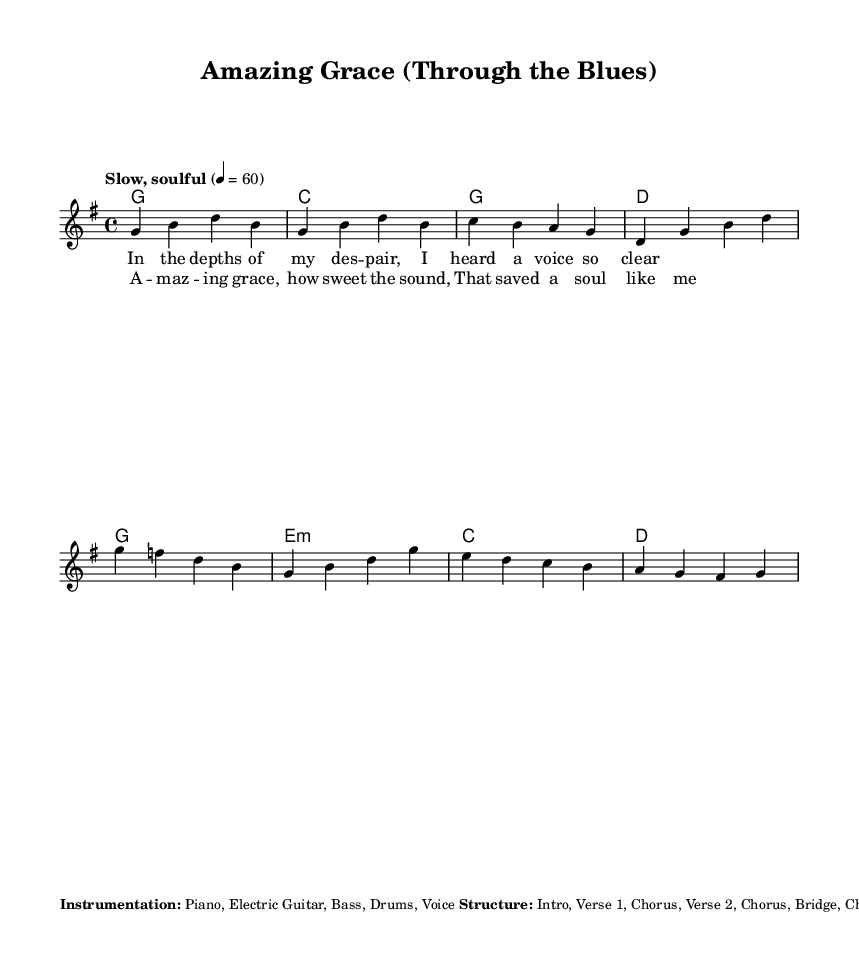What is the key signature of this music? The key signature is G major, which has one sharp (F#).
Answer: G major What is the time signature of this music? The time signature indicated is 4/4, meaning there are four beats per measure.
Answer: 4/4 What is the tempo marking given for this piece? The tempo marking states "Slow, soulful," suggesting a relaxed playing style.
Answer: Slow, soulful How many measures are in the verse section? The verse section contains four measures as demonstrated in the melody line.
Answer: Four What is the structure of this piece? The structure includes an intro, two verses, a bridge, and choruses, organized sequentially in the provided layout.
Answer: Intro, Verse 1, Chorus, Verse 2, Chorus, Bridge, Chorus, Outro What are the bridge chords in this sheet music? The bridge chords specified in the sheet music are Em, C, G, and D, positioned for the song's bridge section.
Answer: Em C G D What musical features are included in the gospel-style section? The gospel-style section includes call and response between lead vocal and backing vocals during the chorus.
Answer: Call and response 